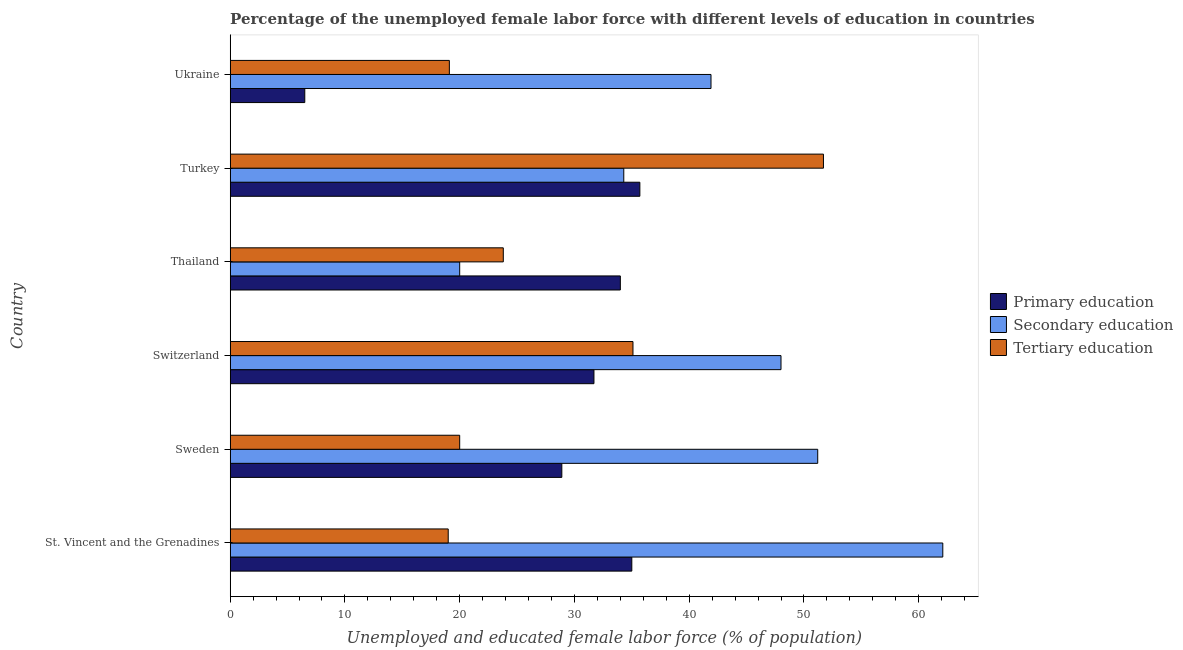How many different coloured bars are there?
Offer a very short reply. 3. How many groups of bars are there?
Your answer should be very brief. 6. Are the number of bars on each tick of the Y-axis equal?
Provide a succinct answer. Yes. What is the label of the 6th group of bars from the top?
Ensure brevity in your answer.  St. Vincent and the Grenadines. In how many cases, is the number of bars for a given country not equal to the number of legend labels?
Keep it short and to the point. 0. What is the percentage of female labor force who received primary education in Sweden?
Provide a succinct answer. 28.9. Across all countries, what is the maximum percentage of female labor force who received primary education?
Your response must be concise. 35.7. Across all countries, what is the minimum percentage of female labor force who received secondary education?
Offer a terse response. 20. In which country was the percentage of female labor force who received secondary education maximum?
Offer a very short reply. St. Vincent and the Grenadines. In which country was the percentage of female labor force who received secondary education minimum?
Your response must be concise. Thailand. What is the total percentage of female labor force who received secondary education in the graph?
Your answer should be very brief. 257.5. What is the difference between the percentage of female labor force who received secondary education in St. Vincent and the Grenadines and that in Switzerland?
Provide a succinct answer. 14.1. What is the difference between the percentage of female labor force who received tertiary education in St. Vincent and the Grenadines and the percentage of female labor force who received primary education in Switzerland?
Make the answer very short. -12.7. What is the average percentage of female labor force who received primary education per country?
Keep it short and to the point. 28.63. What is the difference between the percentage of female labor force who received secondary education and percentage of female labor force who received tertiary education in St. Vincent and the Grenadines?
Ensure brevity in your answer.  43.1. In how many countries, is the percentage of female labor force who received primary education greater than 38 %?
Your answer should be compact. 0. What is the ratio of the percentage of female labor force who received tertiary education in Thailand to that in Turkey?
Ensure brevity in your answer.  0.46. Is the difference between the percentage of female labor force who received tertiary education in Switzerland and Ukraine greater than the difference between the percentage of female labor force who received secondary education in Switzerland and Ukraine?
Your response must be concise. Yes. What is the difference between the highest and the second highest percentage of female labor force who received primary education?
Your answer should be compact. 0.7. What is the difference between the highest and the lowest percentage of female labor force who received secondary education?
Give a very brief answer. 42.1. In how many countries, is the percentage of female labor force who received primary education greater than the average percentage of female labor force who received primary education taken over all countries?
Keep it short and to the point. 5. Is the sum of the percentage of female labor force who received primary education in Sweden and Thailand greater than the maximum percentage of female labor force who received secondary education across all countries?
Your answer should be very brief. Yes. What does the 2nd bar from the bottom in Switzerland represents?
Offer a terse response. Secondary education. How many bars are there?
Ensure brevity in your answer.  18. What is the difference between two consecutive major ticks on the X-axis?
Your response must be concise. 10. Does the graph contain any zero values?
Keep it short and to the point. No. How many legend labels are there?
Keep it short and to the point. 3. What is the title of the graph?
Ensure brevity in your answer.  Percentage of the unemployed female labor force with different levels of education in countries. What is the label or title of the X-axis?
Your answer should be compact. Unemployed and educated female labor force (% of population). What is the Unemployed and educated female labor force (% of population) in Primary education in St. Vincent and the Grenadines?
Your answer should be compact. 35. What is the Unemployed and educated female labor force (% of population) in Secondary education in St. Vincent and the Grenadines?
Your response must be concise. 62.1. What is the Unemployed and educated female labor force (% of population) in Tertiary education in St. Vincent and the Grenadines?
Offer a very short reply. 19. What is the Unemployed and educated female labor force (% of population) in Primary education in Sweden?
Keep it short and to the point. 28.9. What is the Unemployed and educated female labor force (% of population) of Secondary education in Sweden?
Your answer should be very brief. 51.2. What is the Unemployed and educated female labor force (% of population) of Tertiary education in Sweden?
Keep it short and to the point. 20. What is the Unemployed and educated female labor force (% of population) of Primary education in Switzerland?
Your answer should be compact. 31.7. What is the Unemployed and educated female labor force (% of population) in Secondary education in Switzerland?
Provide a short and direct response. 48. What is the Unemployed and educated female labor force (% of population) of Tertiary education in Switzerland?
Offer a very short reply. 35.1. What is the Unemployed and educated female labor force (% of population) in Primary education in Thailand?
Keep it short and to the point. 34. What is the Unemployed and educated female labor force (% of population) of Secondary education in Thailand?
Your response must be concise. 20. What is the Unemployed and educated female labor force (% of population) in Tertiary education in Thailand?
Make the answer very short. 23.8. What is the Unemployed and educated female labor force (% of population) of Primary education in Turkey?
Keep it short and to the point. 35.7. What is the Unemployed and educated female labor force (% of population) in Secondary education in Turkey?
Keep it short and to the point. 34.3. What is the Unemployed and educated female labor force (% of population) in Tertiary education in Turkey?
Your answer should be very brief. 51.7. What is the Unemployed and educated female labor force (% of population) in Secondary education in Ukraine?
Your answer should be compact. 41.9. What is the Unemployed and educated female labor force (% of population) of Tertiary education in Ukraine?
Keep it short and to the point. 19.1. Across all countries, what is the maximum Unemployed and educated female labor force (% of population) of Primary education?
Provide a succinct answer. 35.7. Across all countries, what is the maximum Unemployed and educated female labor force (% of population) of Secondary education?
Keep it short and to the point. 62.1. Across all countries, what is the maximum Unemployed and educated female labor force (% of population) of Tertiary education?
Give a very brief answer. 51.7. Across all countries, what is the minimum Unemployed and educated female labor force (% of population) in Primary education?
Keep it short and to the point. 6.5. What is the total Unemployed and educated female labor force (% of population) in Primary education in the graph?
Keep it short and to the point. 171.8. What is the total Unemployed and educated female labor force (% of population) in Secondary education in the graph?
Offer a very short reply. 257.5. What is the total Unemployed and educated female labor force (% of population) in Tertiary education in the graph?
Your answer should be compact. 168.7. What is the difference between the Unemployed and educated female labor force (% of population) of Primary education in St. Vincent and the Grenadines and that in Sweden?
Offer a terse response. 6.1. What is the difference between the Unemployed and educated female labor force (% of population) of Tertiary education in St. Vincent and the Grenadines and that in Sweden?
Ensure brevity in your answer.  -1. What is the difference between the Unemployed and educated female labor force (% of population) in Secondary education in St. Vincent and the Grenadines and that in Switzerland?
Make the answer very short. 14.1. What is the difference between the Unemployed and educated female labor force (% of population) of Tertiary education in St. Vincent and the Grenadines and that in Switzerland?
Your response must be concise. -16.1. What is the difference between the Unemployed and educated female labor force (% of population) in Secondary education in St. Vincent and the Grenadines and that in Thailand?
Offer a very short reply. 42.1. What is the difference between the Unemployed and educated female labor force (% of population) of Secondary education in St. Vincent and the Grenadines and that in Turkey?
Your response must be concise. 27.8. What is the difference between the Unemployed and educated female labor force (% of population) in Tertiary education in St. Vincent and the Grenadines and that in Turkey?
Offer a terse response. -32.7. What is the difference between the Unemployed and educated female labor force (% of population) in Primary education in St. Vincent and the Grenadines and that in Ukraine?
Your answer should be very brief. 28.5. What is the difference between the Unemployed and educated female labor force (% of population) in Secondary education in St. Vincent and the Grenadines and that in Ukraine?
Make the answer very short. 20.2. What is the difference between the Unemployed and educated female labor force (% of population) of Tertiary education in St. Vincent and the Grenadines and that in Ukraine?
Your answer should be very brief. -0.1. What is the difference between the Unemployed and educated female labor force (% of population) of Primary education in Sweden and that in Switzerland?
Keep it short and to the point. -2.8. What is the difference between the Unemployed and educated female labor force (% of population) of Tertiary education in Sweden and that in Switzerland?
Provide a short and direct response. -15.1. What is the difference between the Unemployed and educated female labor force (% of population) of Secondary education in Sweden and that in Thailand?
Give a very brief answer. 31.2. What is the difference between the Unemployed and educated female labor force (% of population) in Tertiary education in Sweden and that in Thailand?
Make the answer very short. -3.8. What is the difference between the Unemployed and educated female labor force (% of population) of Primary education in Sweden and that in Turkey?
Make the answer very short. -6.8. What is the difference between the Unemployed and educated female labor force (% of population) of Secondary education in Sweden and that in Turkey?
Offer a very short reply. 16.9. What is the difference between the Unemployed and educated female labor force (% of population) in Tertiary education in Sweden and that in Turkey?
Offer a very short reply. -31.7. What is the difference between the Unemployed and educated female labor force (% of population) of Primary education in Sweden and that in Ukraine?
Keep it short and to the point. 22.4. What is the difference between the Unemployed and educated female labor force (% of population) in Primary education in Switzerland and that in Thailand?
Your response must be concise. -2.3. What is the difference between the Unemployed and educated female labor force (% of population) of Tertiary education in Switzerland and that in Thailand?
Your answer should be very brief. 11.3. What is the difference between the Unemployed and educated female labor force (% of population) of Secondary education in Switzerland and that in Turkey?
Offer a very short reply. 13.7. What is the difference between the Unemployed and educated female labor force (% of population) of Tertiary education in Switzerland and that in Turkey?
Give a very brief answer. -16.6. What is the difference between the Unemployed and educated female labor force (% of population) in Primary education in Switzerland and that in Ukraine?
Your answer should be compact. 25.2. What is the difference between the Unemployed and educated female labor force (% of population) in Secondary education in Switzerland and that in Ukraine?
Give a very brief answer. 6.1. What is the difference between the Unemployed and educated female labor force (% of population) in Tertiary education in Switzerland and that in Ukraine?
Ensure brevity in your answer.  16. What is the difference between the Unemployed and educated female labor force (% of population) of Secondary education in Thailand and that in Turkey?
Offer a terse response. -14.3. What is the difference between the Unemployed and educated female labor force (% of population) in Tertiary education in Thailand and that in Turkey?
Your answer should be very brief. -27.9. What is the difference between the Unemployed and educated female labor force (% of population) of Primary education in Thailand and that in Ukraine?
Keep it short and to the point. 27.5. What is the difference between the Unemployed and educated female labor force (% of population) of Secondary education in Thailand and that in Ukraine?
Provide a succinct answer. -21.9. What is the difference between the Unemployed and educated female labor force (% of population) in Tertiary education in Thailand and that in Ukraine?
Your answer should be very brief. 4.7. What is the difference between the Unemployed and educated female labor force (% of population) of Primary education in Turkey and that in Ukraine?
Provide a succinct answer. 29.2. What is the difference between the Unemployed and educated female labor force (% of population) in Secondary education in Turkey and that in Ukraine?
Give a very brief answer. -7.6. What is the difference between the Unemployed and educated female labor force (% of population) in Tertiary education in Turkey and that in Ukraine?
Provide a succinct answer. 32.6. What is the difference between the Unemployed and educated female labor force (% of population) in Primary education in St. Vincent and the Grenadines and the Unemployed and educated female labor force (% of population) in Secondary education in Sweden?
Ensure brevity in your answer.  -16.2. What is the difference between the Unemployed and educated female labor force (% of population) of Secondary education in St. Vincent and the Grenadines and the Unemployed and educated female labor force (% of population) of Tertiary education in Sweden?
Offer a very short reply. 42.1. What is the difference between the Unemployed and educated female labor force (% of population) of Primary education in St. Vincent and the Grenadines and the Unemployed and educated female labor force (% of population) of Tertiary education in Switzerland?
Make the answer very short. -0.1. What is the difference between the Unemployed and educated female labor force (% of population) in Secondary education in St. Vincent and the Grenadines and the Unemployed and educated female labor force (% of population) in Tertiary education in Thailand?
Make the answer very short. 38.3. What is the difference between the Unemployed and educated female labor force (% of population) of Primary education in St. Vincent and the Grenadines and the Unemployed and educated female labor force (% of population) of Secondary education in Turkey?
Your answer should be very brief. 0.7. What is the difference between the Unemployed and educated female labor force (% of population) of Primary education in St. Vincent and the Grenadines and the Unemployed and educated female labor force (% of population) of Tertiary education in Turkey?
Ensure brevity in your answer.  -16.7. What is the difference between the Unemployed and educated female labor force (% of population) of Secondary education in St. Vincent and the Grenadines and the Unemployed and educated female labor force (% of population) of Tertiary education in Turkey?
Offer a very short reply. 10.4. What is the difference between the Unemployed and educated female labor force (% of population) in Primary education in St. Vincent and the Grenadines and the Unemployed and educated female labor force (% of population) in Secondary education in Ukraine?
Your answer should be compact. -6.9. What is the difference between the Unemployed and educated female labor force (% of population) in Secondary education in St. Vincent and the Grenadines and the Unemployed and educated female labor force (% of population) in Tertiary education in Ukraine?
Make the answer very short. 43. What is the difference between the Unemployed and educated female labor force (% of population) in Primary education in Sweden and the Unemployed and educated female labor force (% of population) in Secondary education in Switzerland?
Your response must be concise. -19.1. What is the difference between the Unemployed and educated female labor force (% of population) of Primary education in Sweden and the Unemployed and educated female labor force (% of population) of Secondary education in Thailand?
Give a very brief answer. 8.9. What is the difference between the Unemployed and educated female labor force (% of population) in Primary education in Sweden and the Unemployed and educated female labor force (% of population) in Tertiary education in Thailand?
Give a very brief answer. 5.1. What is the difference between the Unemployed and educated female labor force (% of population) in Secondary education in Sweden and the Unemployed and educated female labor force (% of population) in Tertiary education in Thailand?
Keep it short and to the point. 27.4. What is the difference between the Unemployed and educated female labor force (% of population) of Primary education in Sweden and the Unemployed and educated female labor force (% of population) of Tertiary education in Turkey?
Offer a terse response. -22.8. What is the difference between the Unemployed and educated female labor force (% of population) in Secondary education in Sweden and the Unemployed and educated female labor force (% of population) in Tertiary education in Turkey?
Your response must be concise. -0.5. What is the difference between the Unemployed and educated female labor force (% of population) in Primary education in Sweden and the Unemployed and educated female labor force (% of population) in Secondary education in Ukraine?
Provide a succinct answer. -13. What is the difference between the Unemployed and educated female labor force (% of population) of Secondary education in Sweden and the Unemployed and educated female labor force (% of population) of Tertiary education in Ukraine?
Provide a short and direct response. 32.1. What is the difference between the Unemployed and educated female labor force (% of population) in Primary education in Switzerland and the Unemployed and educated female labor force (% of population) in Secondary education in Thailand?
Make the answer very short. 11.7. What is the difference between the Unemployed and educated female labor force (% of population) in Secondary education in Switzerland and the Unemployed and educated female labor force (% of population) in Tertiary education in Thailand?
Ensure brevity in your answer.  24.2. What is the difference between the Unemployed and educated female labor force (% of population) in Primary education in Switzerland and the Unemployed and educated female labor force (% of population) in Secondary education in Turkey?
Ensure brevity in your answer.  -2.6. What is the difference between the Unemployed and educated female labor force (% of population) in Primary education in Switzerland and the Unemployed and educated female labor force (% of population) in Tertiary education in Turkey?
Your answer should be compact. -20. What is the difference between the Unemployed and educated female labor force (% of population) of Secondary education in Switzerland and the Unemployed and educated female labor force (% of population) of Tertiary education in Turkey?
Your answer should be compact. -3.7. What is the difference between the Unemployed and educated female labor force (% of population) in Secondary education in Switzerland and the Unemployed and educated female labor force (% of population) in Tertiary education in Ukraine?
Provide a succinct answer. 28.9. What is the difference between the Unemployed and educated female labor force (% of population) in Primary education in Thailand and the Unemployed and educated female labor force (% of population) in Tertiary education in Turkey?
Ensure brevity in your answer.  -17.7. What is the difference between the Unemployed and educated female labor force (% of population) in Secondary education in Thailand and the Unemployed and educated female labor force (% of population) in Tertiary education in Turkey?
Keep it short and to the point. -31.7. What is the difference between the Unemployed and educated female labor force (% of population) in Primary education in Thailand and the Unemployed and educated female labor force (% of population) in Secondary education in Ukraine?
Provide a short and direct response. -7.9. What is the difference between the Unemployed and educated female labor force (% of population) in Primary education in Turkey and the Unemployed and educated female labor force (% of population) in Secondary education in Ukraine?
Provide a short and direct response. -6.2. What is the difference between the Unemployed and educated female labor force (% of population) of Primary education in Turkey and the Unemployed and educated female labor force (% of population) of Tertiary education in Ukraine?
Provide a succinct answer. 16.6. What is the difference between the Unemployed and educated female labor force (% of population) in Secondary education in Turkey and the Unemployed and educated female labor force (% of population) in Tertiary education in Ukraine?
Give a very brief answer. 15.2. What is the average Unemployed and educated female labor force (% of population) in Primary education per country?
Offer a terse response. 28.63. What is the average Unemployed and educated female labor force (% of population) of Secondary education per country?
Make the answer very short. 42.92. What is the average Unemployed and educated female labor force (% of population) in Tertiary education per country?
Ensure brevity in your answer.  28.12. What is the difference between the Unemployed and educated female labor force (% of population) in Primary education and Unemployed and educated female labor force (% of population) in Secondary education in St. Vincent and the Grenadines?
Keep it short and to the point. -27.1. What is the difference between the Unemployed and educated female labor force (% of population) in Primary education and Unemployed and educated female labor force (% of population) in Tertiary education in St. Vincent and the Grenadines?
Provide a succinct answer. 16. What is the difference between the Unemployed and educated female labor force (% of population) of Secondary education and Unemployed and educated female labor force (% of population) of Tertiary education in St. Vincent and the Grenadines?
Provide a short and direct response. 43.1. What is the difference between the Unemployed and educated female labor force (% of population) in Primary education and Unemployed and educated female labor force (% of population) in Secondary education in Sweden?
Keep it short and to the point. -22.3. What is the difference between the Unemployed and educated female labor force (% of population) of Primary education and Unemployed and educated female labor force (% of population) of Tertiary education in Sweden?
Offer a very short reply. 8.9. What is the difference between the Unemployed and educated female labor force (% of population) in Secondary education and Unemployed and educated female labor force (% of population) in Tertiary education in Sweden?
Give a very brief answer. 31.2. What is the difference between the Unemployed and educated female labor force (% of population) of Primary education and Unemployed and educated female labor force (% of population) of Secondary education in Switzerland?
Ensure brevity in your answer.  -16.3. What is the difference between the Unemployed and educated female labor force (% of population) in Primary education and Unemployed and educated female labor force (% of population) in Secondary education in Thailand?
Provide a succinct answer. 14. What is the difference between the Unemployed and educated female labor force (% of population) of Secondary education and Unemployed and educated female labor force (% of population) of Tertiary education in Thailand?
Give a very brief answer. -3.8. What is the difference between the Unemployed and educated female labor force (% of population) of Primary education and Unemployed and educated female labor force (% of population) of Secondary education in Turkey?
Provide a succinct answer. 1.4. What is the difference between the Unemployed and educated female labor force (% of population) of Secondary education and Unemployed and educated female labor force (% of population) of Tertiary education in Turkey?
Your answer should be very brief. -17.4. What is the difference between the Unemployed and educated female labor force (% of population) of Primary education and Unemployed and educated female labor force (% of population) of Secondary education in Ukraine?
Give a very brief answer. -35.4. What is the difference between the Unemployed and educated female labor force (% of population) of Primary education and Unemployed and educated female labor force (% of population) of Tertiary education in Ukraine?
Make the answer very short. -12.6. What is the difference between the Unemployed and educated female labor force (% of population) in Secondary education and Unemployed and educated female labor force (% of population) in Tertiary education in Ukraine?
Give a very brief answer. 22.8. What is the ratio of the Unemployed and educated female labor force (% of population) in Primary education in St. Vincent and the Grenadines to that in Sweden?
Your answer should be very brief. 1.21. What is the ratio of the Unemployed and educated female labor force (% of population) of Secondary education in St. Vincent and the Grenadines to that in Sweden?
Provide a short and direct response. 1.21. What is the ratio of the Unemployed and educated female labor force (% of population) of Primary education in St. Vincent and the Grenadines to that in Switzerland?
Offer a terse response. 1.1. What is the ratio of the Unemployed and educated female labor force (% of population) of Secondary education in St. Vincent and the Grenadines to that in Switzerland?
Provide a short and direct response. 1.29. What is the ratio of the Unemployed and educated female labor force (% of population) of Tertiary education in St. Vincent and the Grenadines to that in Switzerland?
Your answer should be very brief. 0.54. What is the ratio of the Unemployed and educated female labor force (% of population) in Primary education in St. Vincent and the Grenadines to that in Thailand?
Provide a succinct answer. 1.03. What is the ratio of the Unemployed and educated female labor force (% of population) of Secondary education in St. Vincent and the Grenadines to that in Thailand?
Make the answer very short. 3.1. What is the ratio of the Unemployed and educated female labor force (% of population) in Tertiary education in St. Vincent and the Grenadines to that in Thailand?
Ensure brevity in your answer.  0.8. What is the ratio of the Unemployed and educated female labor force (% of population) in Primary education in St. Vincent and the Grenadines to that in Turkey?
Give a very brief answer. 0.98. What is the ratio of the Unemployed and educated female labor force (% of population) in Secondary education in St. Vincent and the Grenadines to that in Turkey?
Give a very brief answer. 1.81. What is the ratio of the Unemployed and educated female labor force (% of population) in Tertiary education in St. Vincent and the Grenadines to that in Turkey?
Provide a succinct answer. 0.37. What is the ratio of the Unemployed and educated female labor force (% of population) in Primary education in St. Vincent and the Grenadines to that in Ukraine?
Your answer should be very brief. 5.38. What is the ratio of the Unemployed and educated female labor force (% of population) in Secondary education in St. Vincent and the Grenadines to that in Ukraine?
Your answer should be very brief. 1.48. What is the ratio of the Unemployed and educated female labor force (% of population) in Tertiary education in St. Vincent and the Grenadines to that in Ukraine?
Ensure brevity in your answer.  0.99. What is the ratio of the Unemployed and educated female labor force (% of population) in Primary education in Sweden to that in Switzerland?
Provide a short and direct response. 0.91. What is the ratio of the Unemployed and educated female labor force (% of population) in Secondary education in Sweden to that in Switzerland?
Ensure brevity in your answer.  1.07. What is the ratio of the Unemployed and educated female labor force (% of population) in Tertiary education in Sweden to that in Switzerland?
Make the answer very short. 0.57. What is the ratio of the Unemployed and educated female labor force (% of population) in Secondary education in Sweden to that in Thailand?
Offer a very short reply. 2.56. What is the ratio of the Unemployed and educated female labor force (% of population) in Tertiary education in Sweden to that in Thailand?
Offer a terse response. 0.84. What is the ratio of the Unemployed and educated female labor force (% of population) of Primary education in Sweden to that in Turkey?
Your response must be concise. 0.81. What is the ratio of the Unemployed and educated female labor force (% of population) of Secondary education in Sweden to that in Turkey?
Make the answer very short. 1.49. What is the ratio of the Unemployed and educated female labor force (% of population) in Tertiary education in Sweden to that in Turkey?
Ensure brevity in your answer.  0.39. What is the ratio of the Unemployed and educated female labor force (% of population) in Primary education in Sweden to that in Ukraine?
Give a very brief answer. 4.45. What is the ratio of the Unemployed and educated female labor force (% of population) in Secondary education in Sweden to that in Ukraine?
Provide a short and direct response. 1.22. What is the ratio of the Unemployed and educated female labor force (% of population) of Tertiary education in Sweden to that in Ukraine?
Offer a terse response. 1.05. What is the ratio of the Unemployed and educated female labor force (% of population) of Primary education in Switzerland to that in Thailand?
Provide a short and direct response. 0.93. What is the ratio of the Unemployed and educated female labor force (% of population) of Tertiary education in Switzerland to that in Thailand?
Your answer should be compact. 1.47. What is the ratio of the Unemployed and educated female labor force (% of population) of Primary education in Switzerland to that in Turkey?
Offer a terse response. 0.89. What is the ratio of the Unemployed and educated female labor force (% of population) in Secondary education in Switzerland to that in Turkey?
Provide a short and direct response. 1.4. What is the ratio of the Unemployed and educated female labor force (% of population) of Tertiary education in Switzerland to that in Turkey?
Give a very brief answer. 0.68. What is the ratio of the Unemployed and educated female labor force (% of population) in Primary education in Switzerland to that in Ukraine?
Make the answer very short. 4.88. What is the ratio of the Unemployed and educated female labor force (% of population) in Secondary education in Switzerland to that in Ukraine?
Provide a short and direct response. 1.15. What is the ratio of the Unemployed and educated female labor force (% of population) of Tertiary education in Switzerland to that in Ukraine?
Make the answer very short. 1.84. What is the ratio of the Unemployed and educated female labor force (% of population) in Primary education in Thailand to that in Turkey?
Ensure brevity in your answer.  0.95. What is the ratio of the Unemployed and educated female labor force (% of population) in Secondary education in Thailand to that in Turkey?
Keep it short and to the point. 0.58. What is the ratio of the Unemployed and educated female labor force (% of population) in Tertiary education in Thailand to that in Turkey?
Make the answer very short. 0.46. What is the ratio of the Unemployed and educated female labor force (% of population) of Primary education in Thailand to that in Ukraine?
Your answer should be very brief. 5.23. What is the ratio of the Unemployed and educated female labor force (% of population) in Secondary education in Thailand to that in Ukraine?
Your answer should be compact. 0.48. What is the ratio of the Unemployed and educated female labor force (% of population) in Tertiary education in Thailand to that in Ukraine?
Offer a very short reply. 1.25. What is the ratio of the Unemployed and educated female labor force (% of population) of Primary education in Turkey to that in Ukraine?
Your response must be concise. 5.49. What is the ratio of the Unemployed and educated female labor force (% of population) of Secondary education in Turkey to that in Ukraine?
Your answer should be very brief. 0.82. What is the ratio of the Unemployed and educated female labor force (% of population) in Tertiary education in Turkey to that in Ukraine?
Make the answer very short. 2.71. What is the difference between the highest and the second highest Unemployed and educated female labor force (% of population) of Primary education?
Give a very brief answer. 0.7. What is the difference between the highest and the second highest Unemployed and educated female labor force (% of population) in Secondary education?
Offer a very short reply. 10.9. What is the difference between the highest and the lowest Unemployed and educated female labor force (% of population) of Primary education?
Ensure brevity in your answer.  29.2. What is the difference between the highest and the lowest Unemployed and educated female labor force (% of population) in Secondary education?
Your answer should be very brief. 42.1. What is the difference between the highest and the lowest Unemployed and educated female labor force (% of population) of Tertiary education?
Keep it short and to the point. 32.7. 